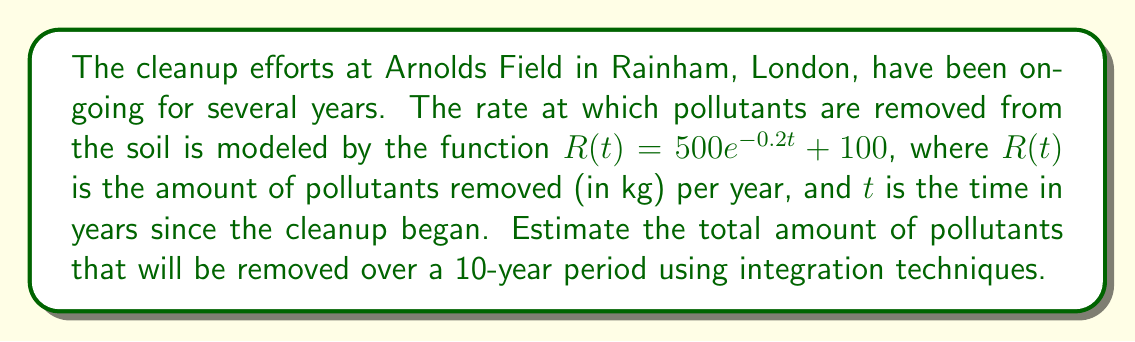Help me with this question. To solve this problem, we need to integrate the rate function $R(t)$ over the given time period. Here's the step-by-step solution:

1) The total amount of pollutants removed is given by the definite integral of $R(t)$ from $t=0$ to $t=10$:

   $$\int_0^{10} R(t) dt = \int_0^{10} (500e^{-0.2t} + 100) dt$$

2) Let's split this into two integrals:

   $$\int_0^{10} 500e^{-0.2t} dt + \int_0^{10} 100 dt$$

3) For the first integral, we use the substitution method:
   Let $u = -0.2t$, then $du = -0.2dt$, or $dt = -5du$
   When $t=0$, $u=0$; when $t=10$, $u=-2$

   $$-2500 \int_0^{-2} e^u du = -2500 [e^u]_0^{-2} = -2500(e^{-2} - 1)$$

4) The second integral is straightforward:

   $$100 \int_0^{10} dt = 100t|_0^{10} = 1000$$

5) Adding the results from steps 3 and 4:

   $$-2500(e^{-2} - 1) + 1000$$

6) Simplifying:

   $$-2500e^{-2} + 2500 + 1000 = 3500 - 2500e^{-2}$$

7) Using a calculator for the final value:

   $$3500 - 2500 * 0.1353 = 3161.75$$
Answer: The total amount of pollutants removed over a 10-year period is approximately 3161.75 kg. 